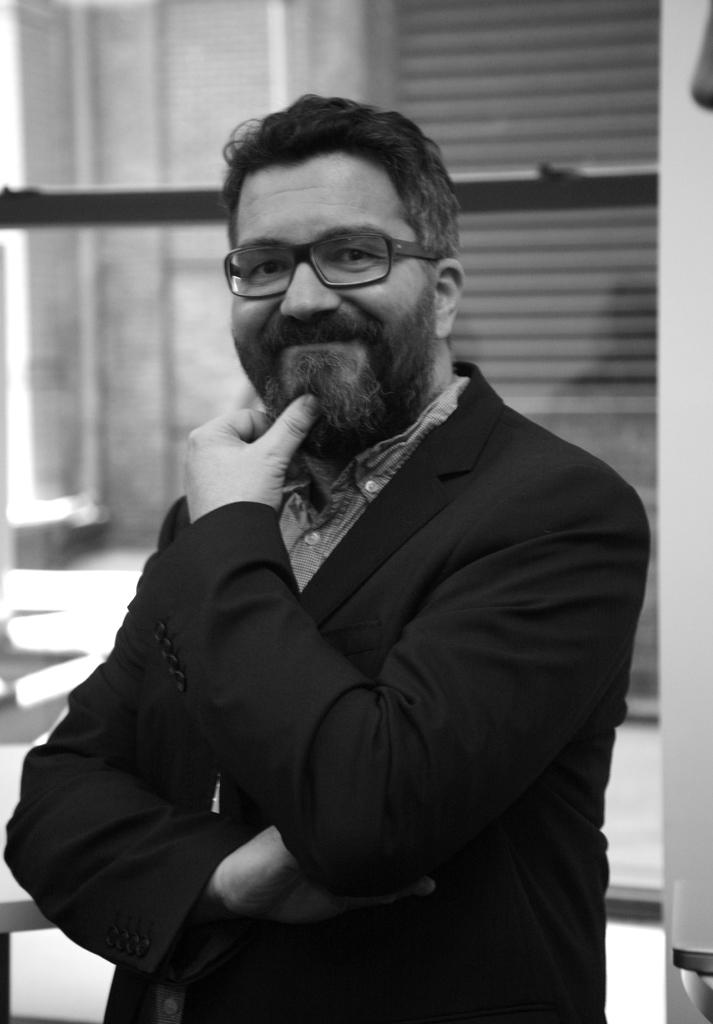What is the color scheme of the image? The image is black and white. Who is present in the image? There is a man in the image. What is the man doing in the image? The man is standing and smiling. What is the man wearing in the image? The man is wearing a shirt, a suit, and spectacles. What can be seen in the background of the image? There is a window and a glass door in the background of the image. What type of book is the man holding in the image? There is no book present in the image; the man is not holding anything. 